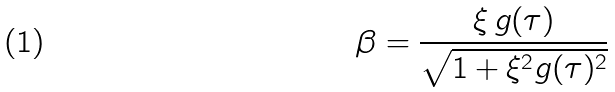<formula> <loc_0><loc_0><loc_500><loc_500>\beta = \frac { \xi \, g ( \tau ) } { \sqrt { 1 + \xi ^ { 2 } g ( \tau ) ^ { 2 } } }</formula> 